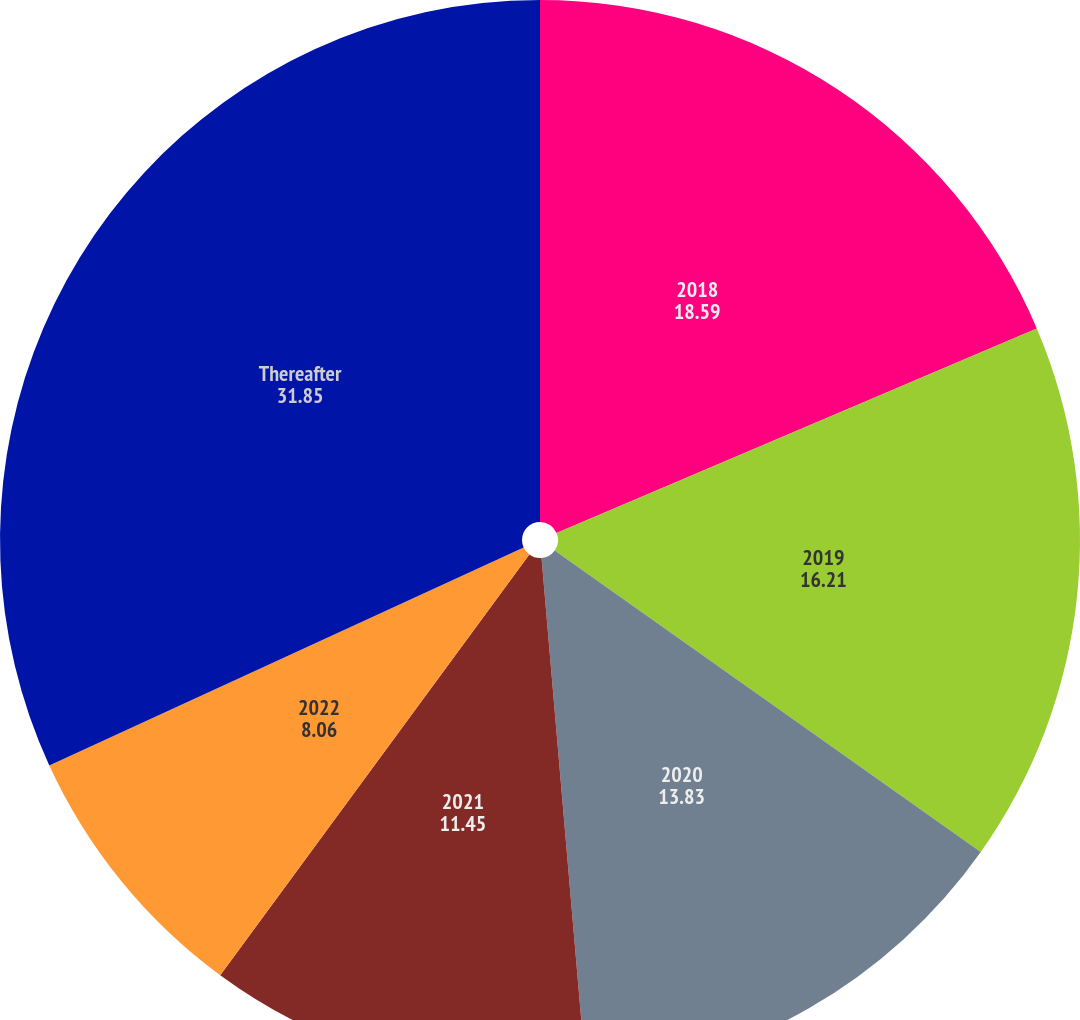Convert chart. <chart><loc_0><loc_0><loc_500><loc_500><pie_chart><fcel>2018<fcel>2019<fcel>2020<fcel>2021<fcel>2022<fcel>Thereafter<nl><fcel>18.59%<fcel>16.21%<fcel>13.83%<fcel>11.45%<fcel>8.06%<fcel>31.85%<nl></chart> 